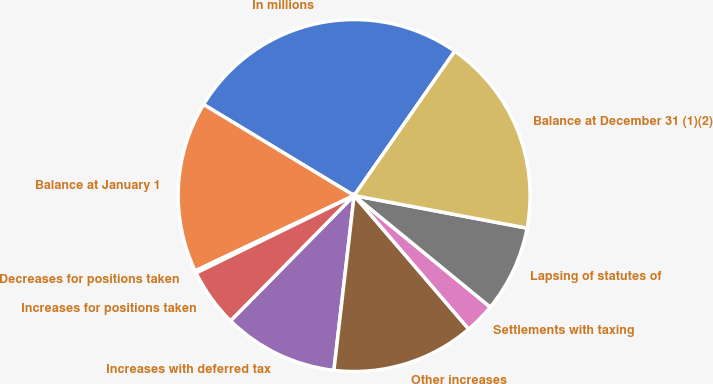Convert chart to OTSL. <chart><loc_0><loc_0><loc_500><loc_500><pie_chart><fcel>In millions<fcel>Balance at January 1<fcel>Decreases for positions taken<fcel>Increases for positions taken<fcel>Increases with deferred tax<fcel>Other increases<fcel>Settlements with taxing<fcel>Lapsing of statutes of<fcel>Balance at December 31 (1)(2)<nl><fcel>26.03%<fcel>15.7%<fcel>0.21%<fcel>5.37%<fcel>10.54%<fcel>13.12%<fcel>2.79%<fcel>7.96%<fcel>18.28%<nl></chart> 